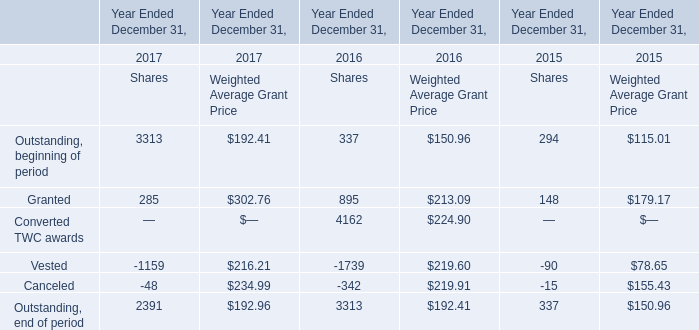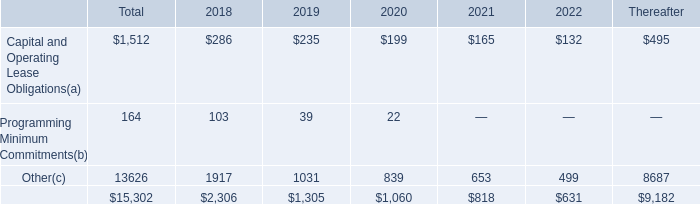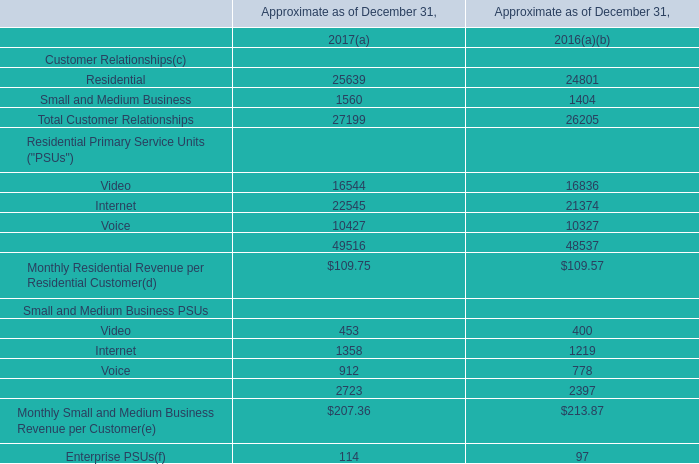In the year with lowest amount of Outstanding, beginning of period at Weighted Average Grant Price, what's the amount of Outstanding, end of period at Weighted Average Grant Price? 
Answer: 150.96. 